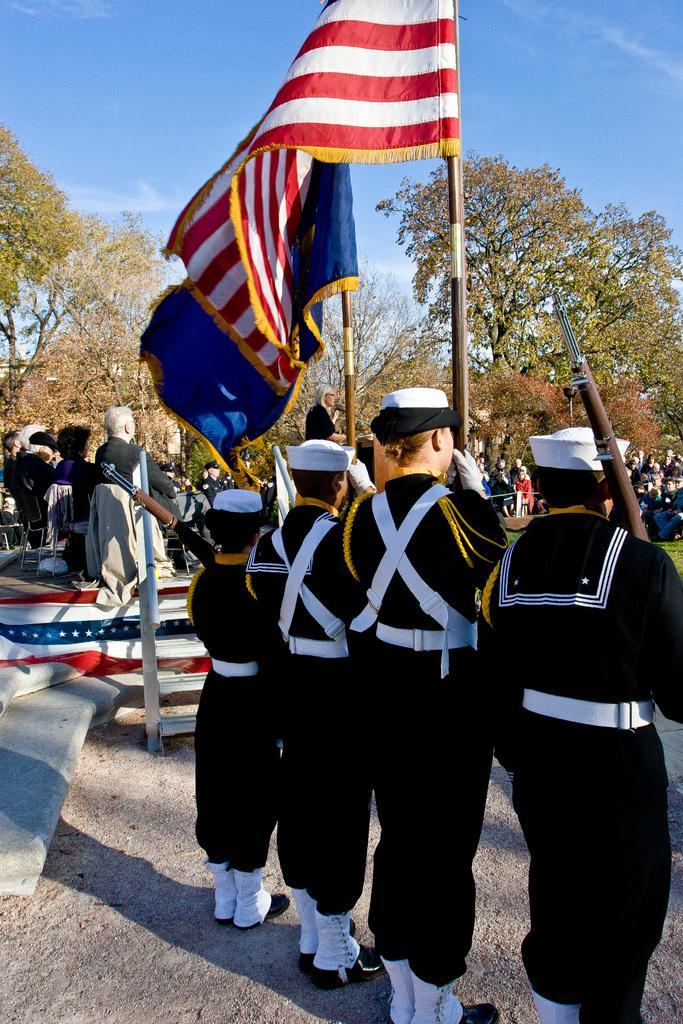Please provide a concise description of this image. In this image we can see one stage, one flag on the stage staircase, some people sitting on the chairs on the stage, some objects on the chairs, some objects on the stage, some big trees, some green grass on the ground, some people are standing, some people are sitting in front of the stage, three people with white caps holding flag poles, three flags with poles, one person with white cap holding a gun on the right side of the image and at the top there is the sky. 